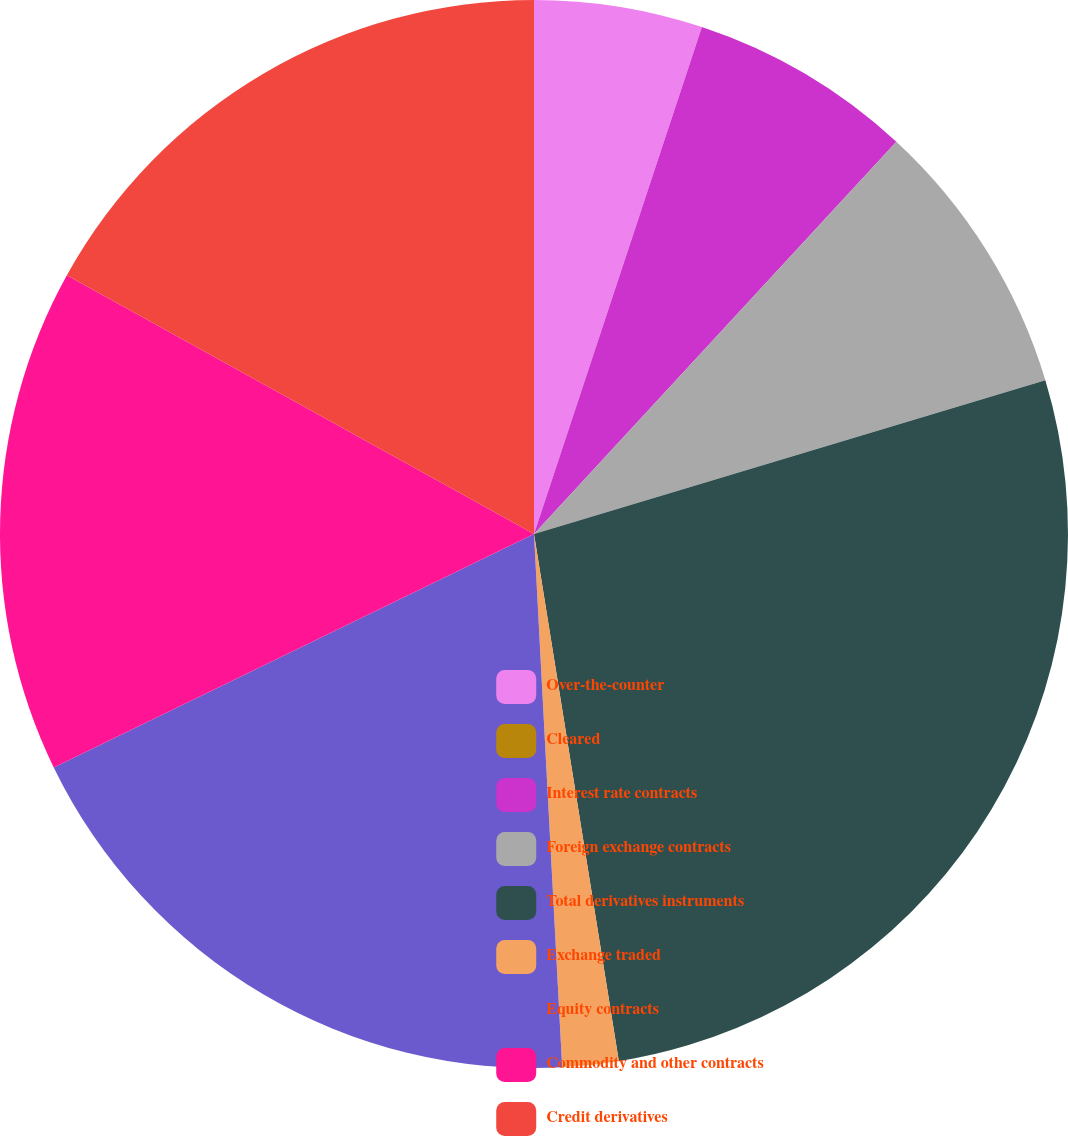Convert chart to OTSL. <chart><loc_0><loc_0><loc_500><loc_500><pie_chart><fcel>Over-the-counter<fcel>Cleared<fcel>Interest rate contracts<fcel>Foreign exchange contracts<fcel>Total derivatives instruments<fcel>Exchange traded<fcel>Equity contracts<fcel>Commodity and other contracts<fcel>Credit derivatives<nl><fcel>5.09%<fcel>0.0%<fcel>6.78%<fcel>8.48%<fcel>27.11%<fcel>1.7%<fcel>18.64%<fcel>15.25%<fcel>16.95%<nl></chart> 